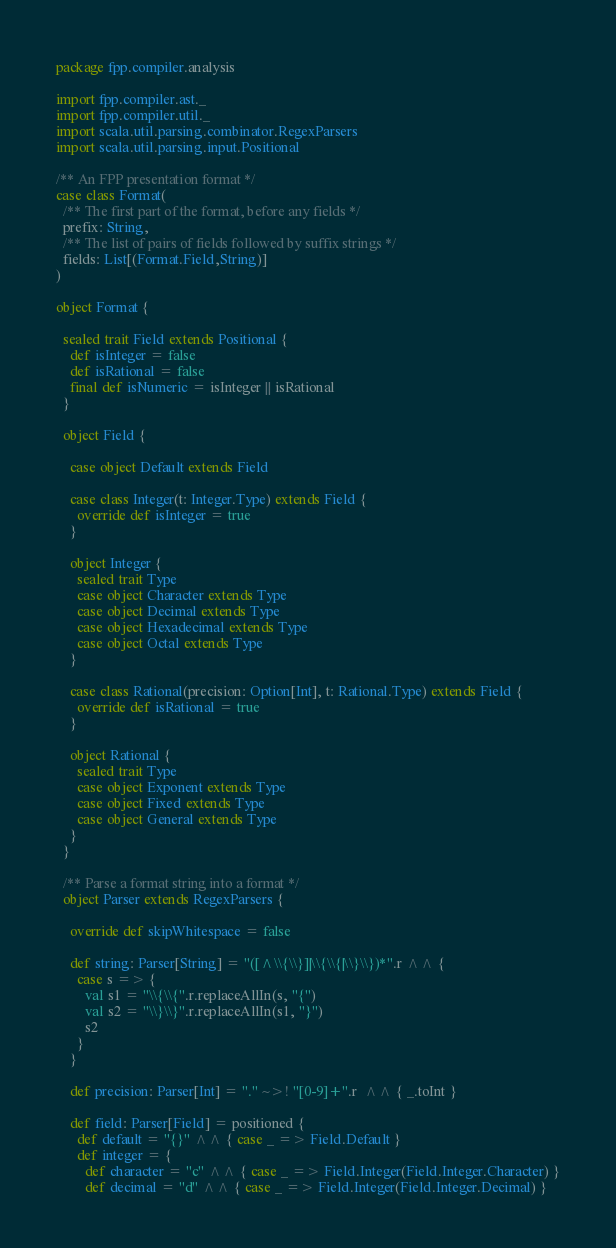<code> <loc_0><loc_0><loc_500><loc_500><_Scala_>package fpp.compiler.analysis

import fpp.compiler.ast._
import fpp.compiler.util._
import scala.util.parsing.combinator.RegexParsers
import scala.util.parsing.input.Positional

/** An FPP presentation format */
case class Format(
  /** The first part of the format, before any fields */
  prefix: String,
  /** The list of pairs of fields followed by suffix strings */
  fields: List[(Format.Field,String)]
)

object Format {

  sealed trait Field extends Positional {
    def isInteger = false
    def isRational = false
    final def isNumeric = isInteger || isRational
  }

  object Field {

    case object Default extends Field

    case class Integer(t: Integer.Type) extends Field {
      override def isInteger = true
    }

    object Integer {
      sealed trait Type
      case object Character extends Type
      case object Decimal extends Type
      case object Hexadecimal extends Type
      case object Octal extends Type
    }

    case class Rational(precision: Option[Int], t: Rational.Type) extends Field {
      override def isRational = true
    }

    object Rational {
      sealed trait Type
      case object Exponent extends Type
      case object Fixed extends Type
      case object General extends Type
    }
  }

  /** Parse a format string into a format */
  object Parser extends RegexParsers {

    override def skipWhitespace = false

    def string: Parser[String] = "([^\\{\\}]|\\{\\{|\\}\\})*".r ^^ {
      case s => {
        val s1 = "\\{\\{".r.replaceAllIn(s, "{")
        val s2 = "\\}\\}".r.replaceAllIn(s1, "}")
        s2
      }
    }

    def precision: Parser[Int] = "." ~>! "[0-9]+".r  ^^ { _.toInt }

    def field: Parser[Field] = positioned {
      def default = "{}" ^^ { case _ => Field.Default }
      def integer = {
        def character = "c" ^^ { case _ => Field.Integer(Field.Integer.Character) }
        def decimal = "d" ^^ { case _ => Field.Integer(Field.Integer.Decimal) }</code> 